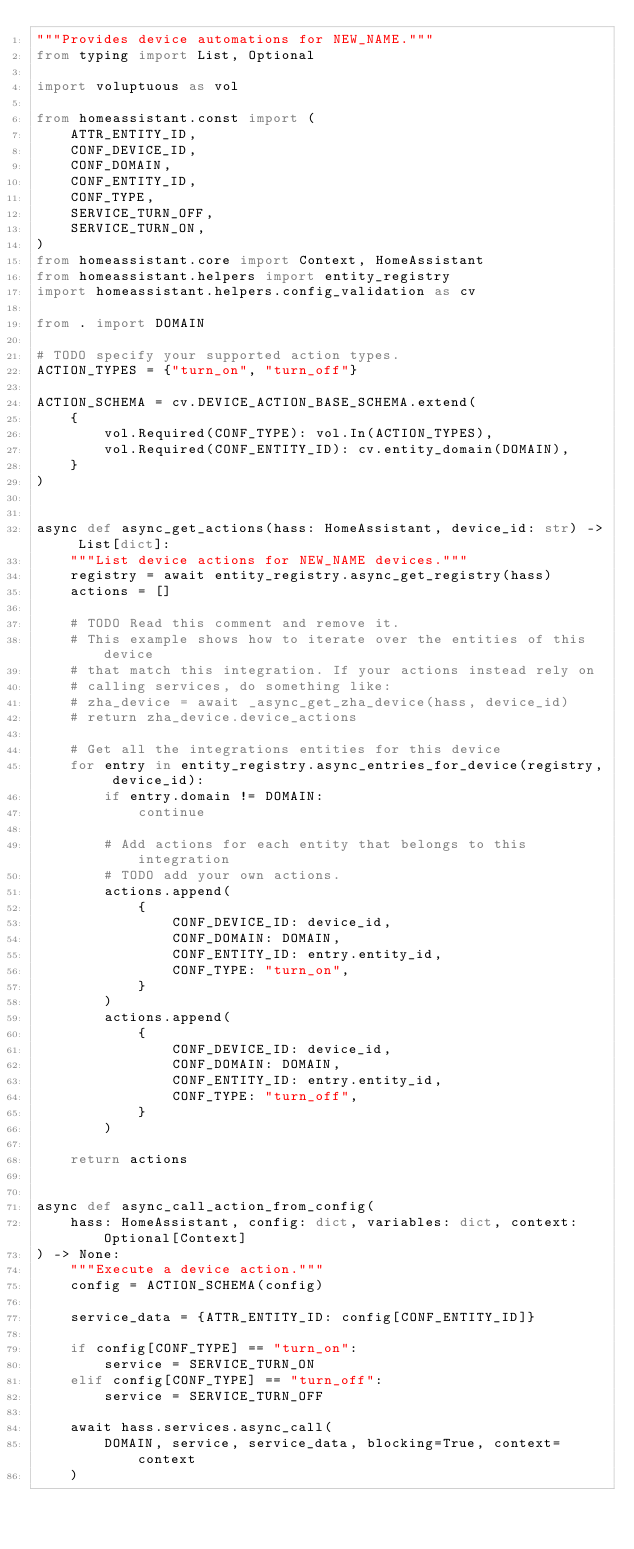Convert code to text. <code><loc_0><loc_0><loc_500><loc_500><_Python_>"""Provides device automations for NEW_NAME."""
from typing import List, Optional

import voluptuous as vol

from homeassistant.const import (
    ATTR_ENTITY_ID,
    CONF_DEVICE_ID,
    CONF_DOMAIN,
    CONF_ENTITY_ID,
    CONF_TYPE,
    SERVICE_TURN_OFF,
    SERVICE_TURN_ON,
)
from homeassistant.core import Context, HomeAssistant
from homeassistant.helpers import entity_registry
import homeassistant.helpers.config_validation as cv

from . import DOMAIN

# TODO specify your supported action types.
ACTION_TYPES = {"turn_on", "turn_off"}

ACTION_SCHEMA = cv.DEVICE_ACTION_BASE_SCHEMA.extend(
    {
        vol.Required(CONF_TYPE): vol.In(ACTION_TYPES),
        vol.Required(CONF_ENTITY_ID): cv.entity_domain(DOMAIN),
    }
)


async def async_get_actions(hass: HomeAssistant, device_id: str) -> List[dict]:
    """List device actions for NEW_NAME devices."""
    registry = await entity_registry.async_get_registry(hass)
    actions = []

    # TODO Read this comment and remove it.
    # This example shows how to iterate over the entities of this device
    # that match this integration. If your actions instead rely on
    # calling services, do something like:
    # zha_device = await _async_get_zha_device(hass, device_id)
    # return zha_device.device_actions

    # Get all the integrations entities for this device
    for entry in entity_registry.async_entries_for_device(registry, device_id):
        if entry.domain != DOMAIN:
            continue

        # Add actions for each entity that belongs to this integration
        # TODO add your own actions.
        actions.append(
            {
                CONF_DEVICE_ID: device_id,
                CONF_DOMAIN: DOMAIN,
                CONF_ENTITY_ID: entry.entity_id,
                CONF_TYPE: "turn_on",
            }
        )
        actions.append(
            {
                CONF_DEVICE_ID: device_id,
                CONF_DOMAIN: DOMAIN,
                CONF_ENTITY_ID: entry.entity_id,
                CONF_TYPE: "turn_off",
            }
        )

    return actions


async def async_call_action_from_config(
    hass: HomeAssistant, config: dict, variables: dict, context: Optional[Context]
) -> None:
    """Execute a device action."""
    config = ACTION_SCHEMA(config)

    service_data = {ATTR_ENTITY_ID: config[CONF_ENTITY_ID]}

    if config[CONF_TYPE] == "turn_on":
        service = SERVICE_TURN_ON
    elif config[CONF_TYPE] == "turn_off":
        service = SERVICE_TURN_OFF

    await hass.services.async_call(
        DOMAIN, service, service_data, blocking=True, context=context
    )
</code> 